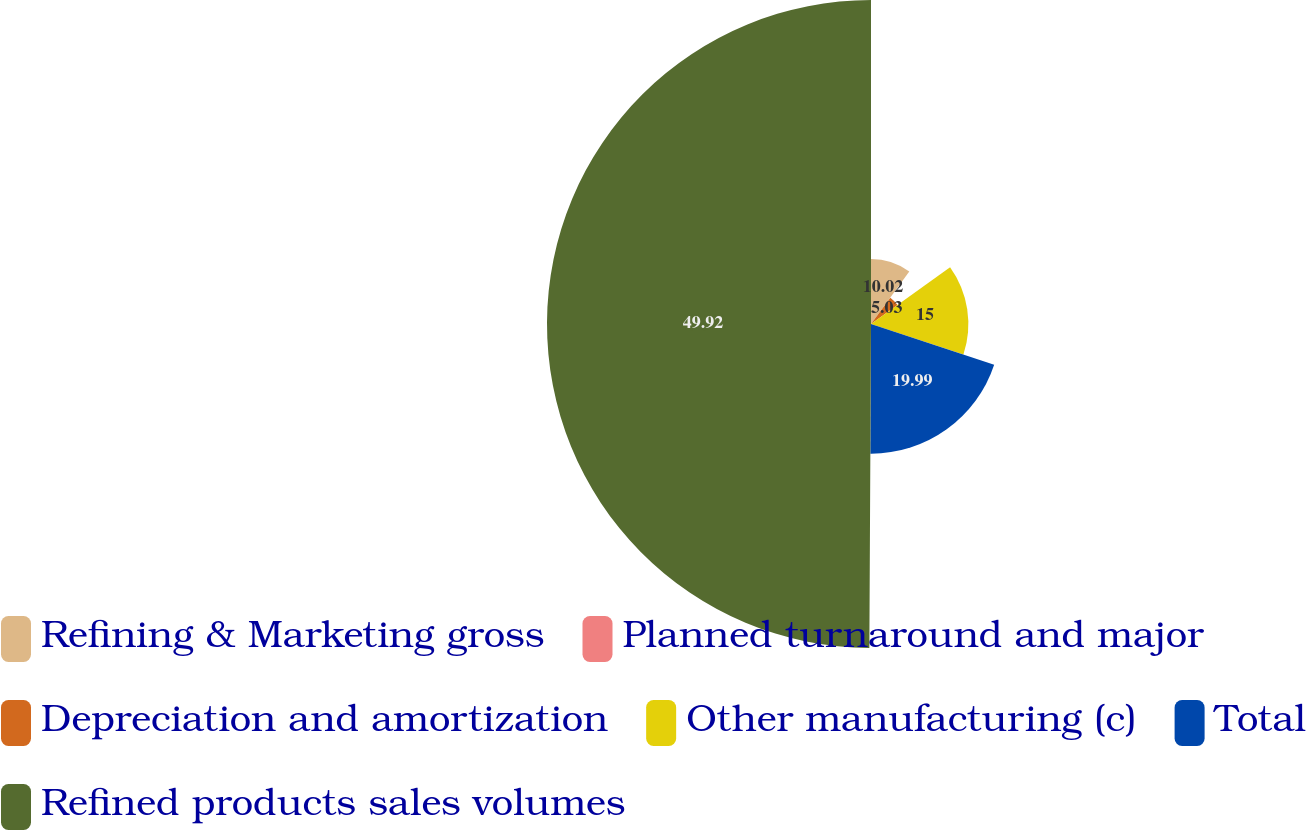Convert chart to OTSL. <chart><loc_0><loc_0><loc_500><loc_500><pie_chart><fcel>Refining & Marketing gross<fcel>Planned turnaround and major<fcel>Depreciation and amortization<fcel>Other manufacturing (c)<fcel>Total<fcel>Refined products sales volumes<nl><fcel>10.02%<fcel>0.04%<fcel>5.03%<fcel>15.0%<fcel>19.99%<fcel>49.92%<nl></chart> 